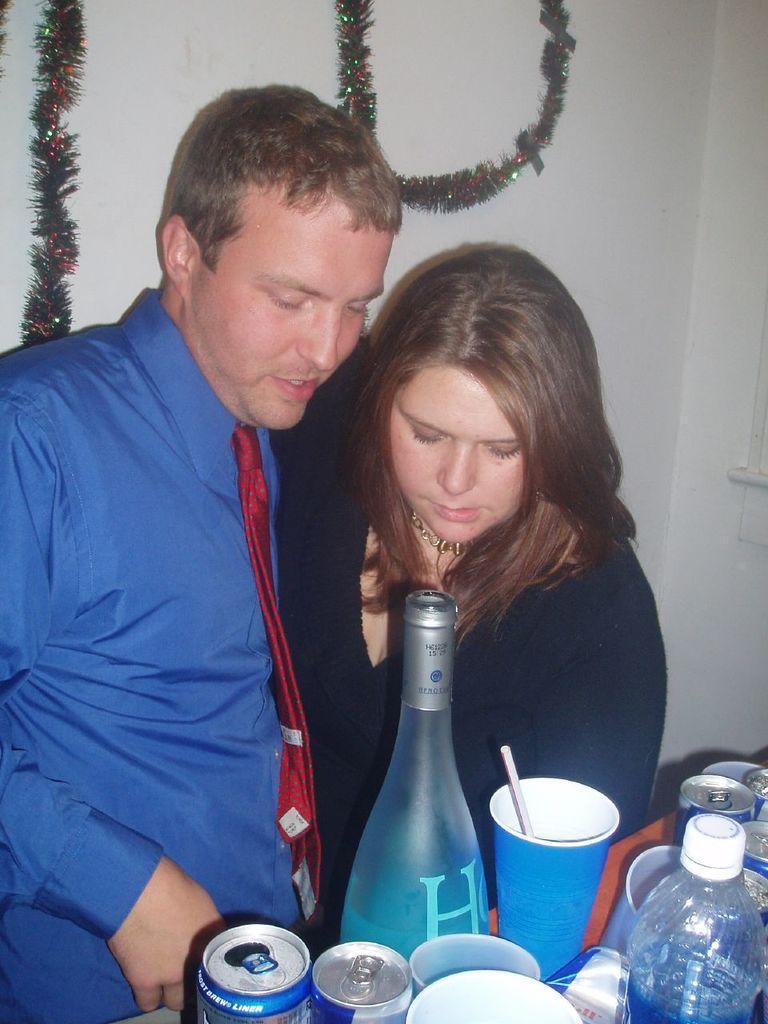Describe this image in one or two sentences. In the image we can see there are two people who are standing and in front of them there is a table on which there is a wine bottle and coke cans. 